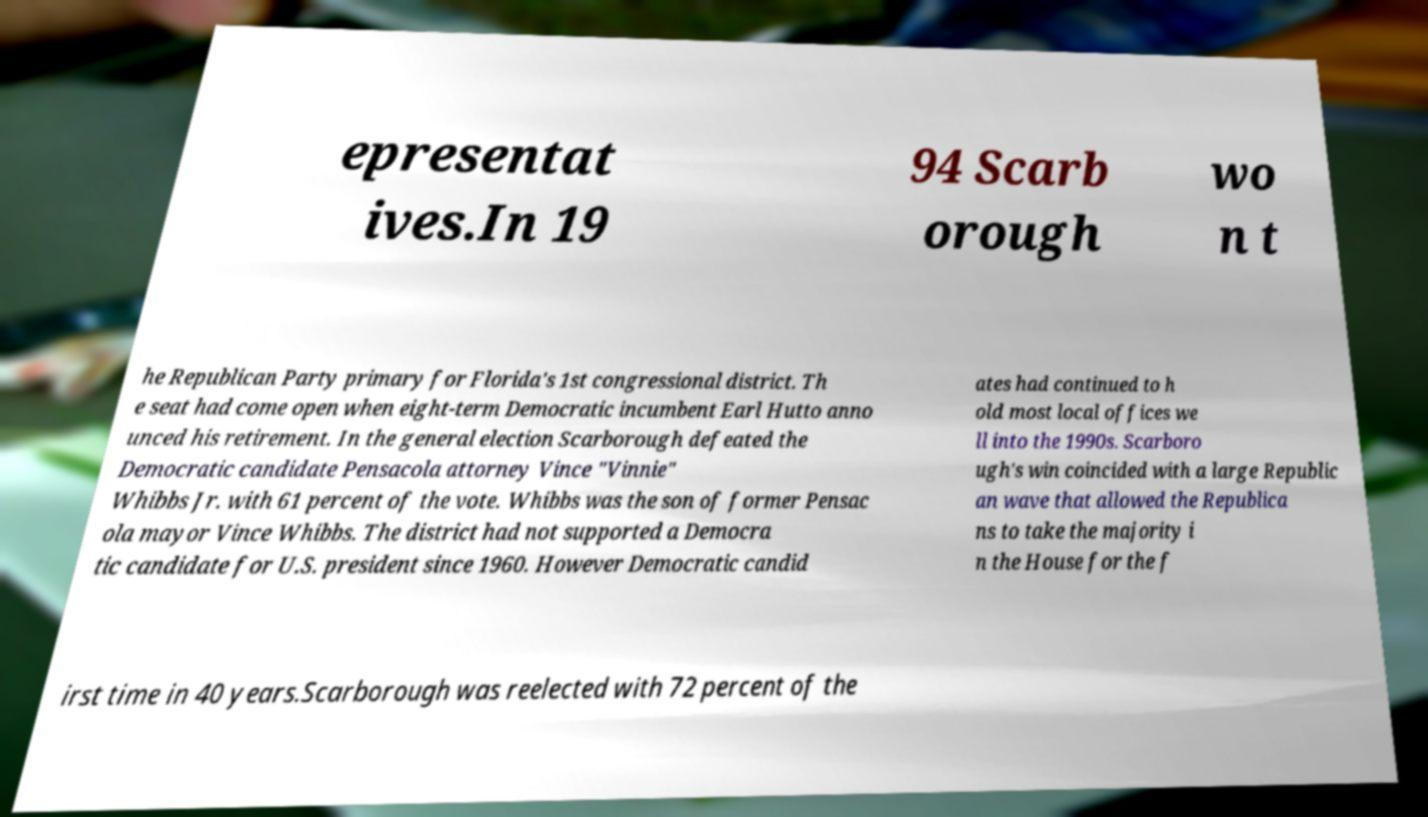Please identify and transcribe the text found in this image. epresentat ives.In 19 94 Scarb orough wo n t he Republican Party primary for Florida's 1st congressional district. Th e seat had come open when eight-term Democratic incumbent Earl Hutto anno unced his retirement. In the general election Scarborough defeated the Democratic candidate Pensacola attorney Vince "Vinnie" Whibbs Jr. with 61 percent of the vote. Whibbs was the son of former Pensac ola mayor Vince Whibbs. The district had not supported a Democra tic candidate for U.S. president since 1960. However Democratic candid ates had continued to h old most local offices we ll into the 1990s. Scarboro ugh's win coincided with a large Republic an wave that allowed the Republica ns to take the majority i n the House for the f irst time in 40 years.Scarborough was reelected with 72 percent of the 